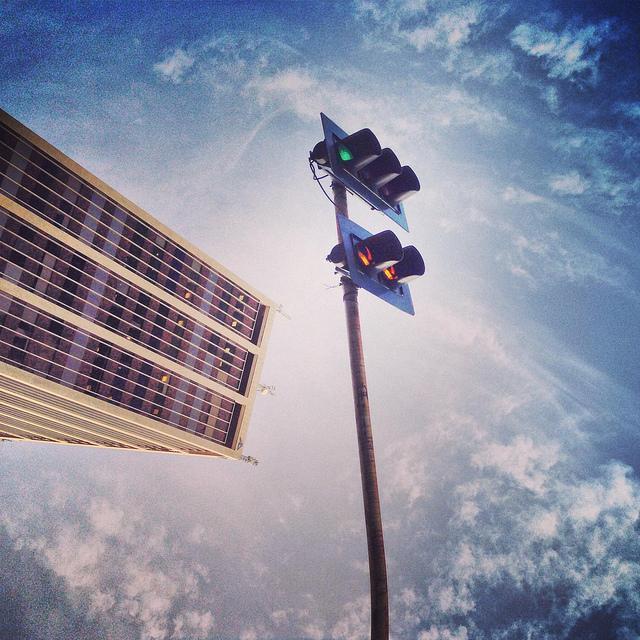How many traffic lights are there?
Give a very brief answer. 2. 